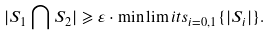Convert formula to latex. <formula><loc_0><loc_0><loc_500><loc_500>| S _ { 1 } \bigcap S _ { 2 } | \geqslant \varepsilon \cdot \min \lim i t s _ { i = 0 , 1 } \{ | S _ { i } | \} .</formula> 